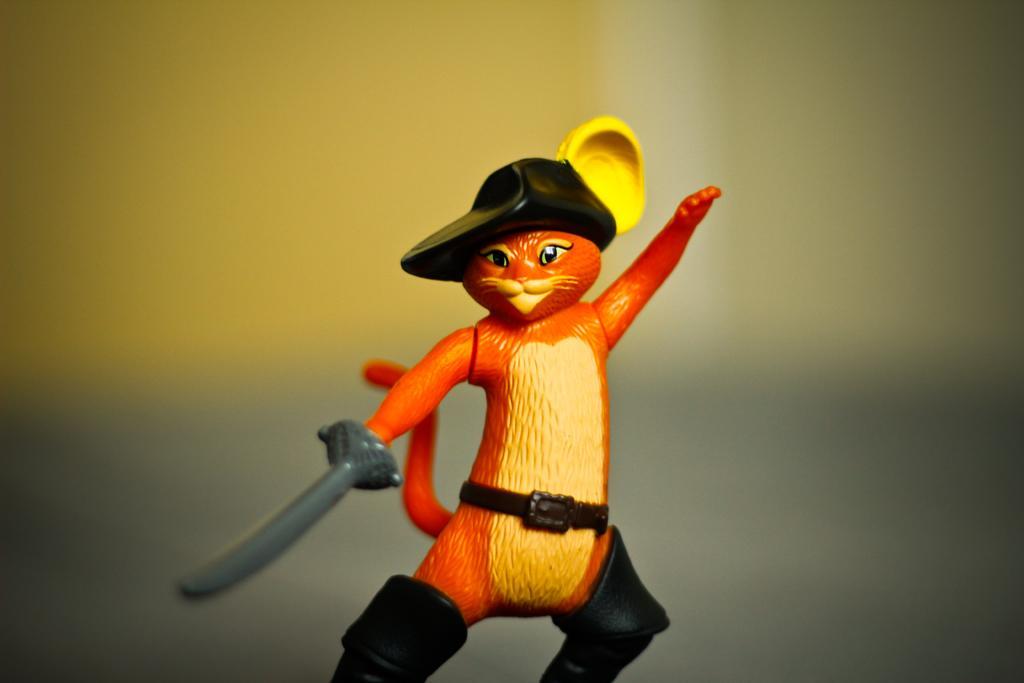Describe this image in one or two sentences. In this image the background is a little blurred. In the middle of the image there is a toy cat. 